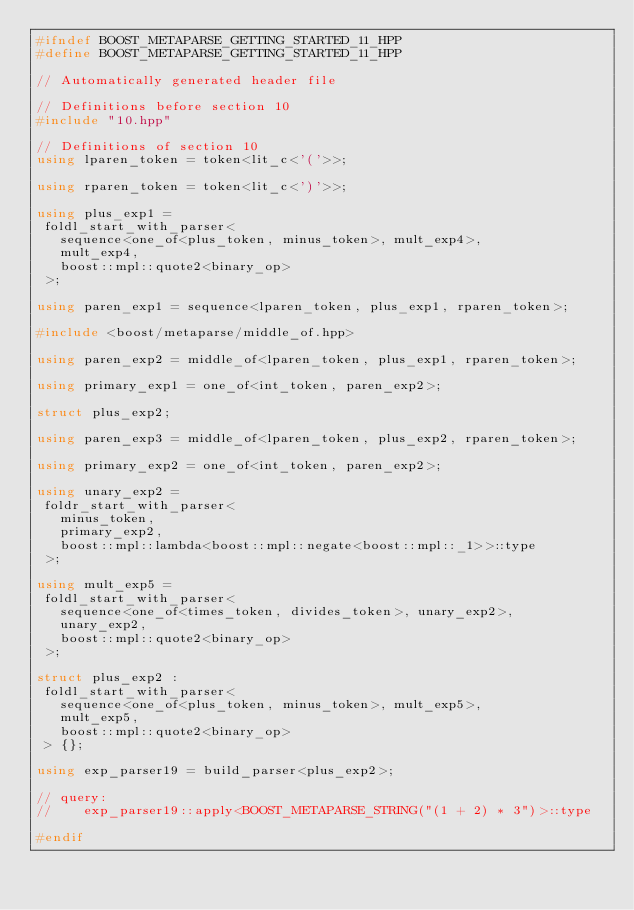Convert code to text. <code><loc_0><loc_0><loc_500><loc_500><_C++_>#ifndef BOOST_METAPARSE_GETTING_STARTED_11_HPP
#define BOOST_METAPARSE_GETTING_STARTED_11_HPP

// Automatically generated header file

// Definitions before section 10
#include "10.hpp"

// Definitions of section 10
using lparen_token = token<lit_c<'('>>;

using rparen_token = token<lit_c<')'>>;

using plus_exp1 = 
 foldl_start_with_parser< 
   sequence<one_of<plus_token, minus_token>, mult_exp4>, 
   mult_exp4, 
   boost::mpl::quote2<binary_op> 
 >;

using paren_exp1 = sequence<lparen_token, plus_exp1, rparen_token>;

#include <boost/metaparse/middle_of.hpp>

using paren_exp2 = middle_of<lparen_token, plus_exp1, rparen_token>;

using primary_exp1 = one_of<int_token, paren_exp2>;

struct plus_exp2;

using paren_exp3 = middle_of<lparen_token, plus_exp2, rparen_token>;

using primary_exp2 = one_of<int_token, paren_exp2>;

using unary_exp2 = 
 foldr_start_with_parser< 
   minus_token, 
   primary_exp2, 
   boost::mpl::lambda<boost::mpl::negate<boost::mpl::_1>>::type 
 >;

using mult_exp5 = 
 foldl_start_with_parser< 
   sequence<one_of<times_token, divides_token>, unary_exp2>, 
   unary_exp2, 
   boost::mpl::quote2<binary_op> 
 >;

struct plus_exp2 : 
 foldl_start_with_parser< 
   sequence<one_of<plus_token, minus_token>, mult_exp5>, 
   mult_exp5, 
   boost::mpl::quote2<binary_op> 
 > {};

using exp_parser19 = build_parser<plus_exp2>;

// query:
//    exp_parser19::apply<BOOST_METAPARSE_STRING("(1 + 2) * 3")>::type

#endif

</code> 